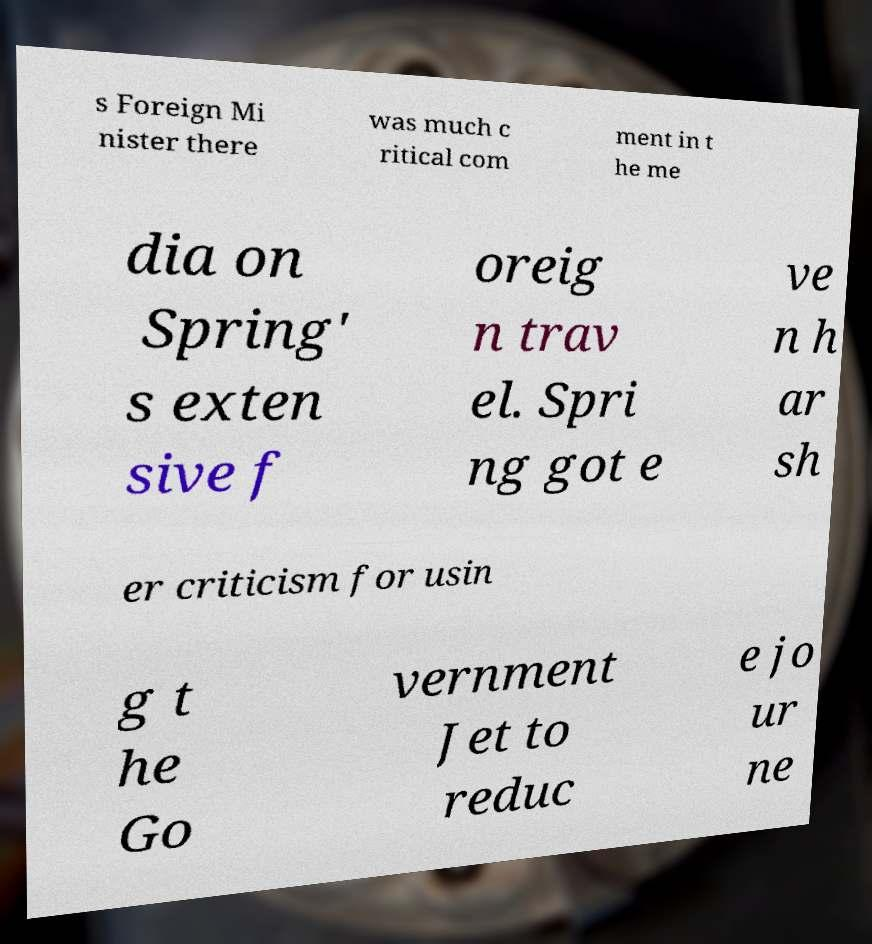Could you assist in decoding the text presented in this image and type it out clearly? s Foreign Mi nister there was much c ritical com ment in t he me dia on Spring' s exten sive f oreig n trav el. Spri ng got e ve n h ar sh er criticism for usin g t he Go vernment Jet to reduc e jo ur ne 